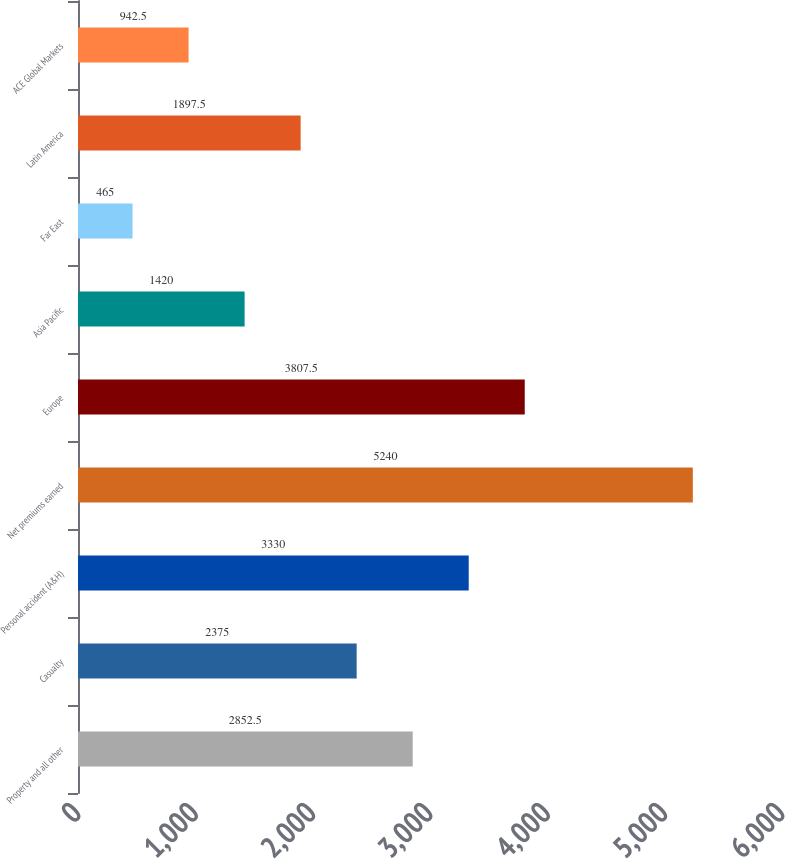Convert chart to OTSL. <chart><loc_0><loc_0><loc_500><loc_500><bar_chart><fcel>Property and all other<fcel>Casualty<fcel>Personal accident (A&H)<fcel>Net premiums earned<fcel>Europe<fcel>Asia Pacific<fcel>Far East<fcel>Latin America<fcel>ACE Global Markets<nl><fcel>2852.5<fcel>2375<fcel>3330<fcel>5240<fcel>3807.5<fcel>1420<fcel>465<fcel>1897.5<fcel>942.5<nl></chart> 